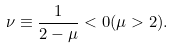<formula> <loc_0><loc_0><loc_500><loc_500>\nu \equiv \frac { 1 } { 2 - \mu } < 0 ( \mu > 2 ) .</formula> 